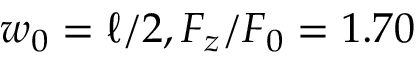Convert formula to latex. <formula><loc_0><loc_0><loc_500><loc_500>w _ { 0 } = \ell / 2 , F _ { z } / F _ { 0 } = 1 . 7 0</formula> 